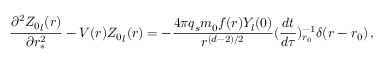<formula> <loc_0><loc_0><loc_500><loc_500>\frac { \partial ^ { 2 } { Z _ { 0 } } _ { l } ( r ) } { \partial r _ { * } ^ { 2 } } - V ( r ) { Z _ { 0 } } _ { l } ( r ) = - \frac { 4 \pi q _ { s } m _ { 0 } f ( r ) Y _ { l } ( 0 ) } { r ^ { ( d - 2 ) / 2 } } ( \frac { d t } { d \tau } ) _ { r _ { 0 } } ^ { - 1 } \delta ( r - r _ { 0 } ) \, ,</formula> 